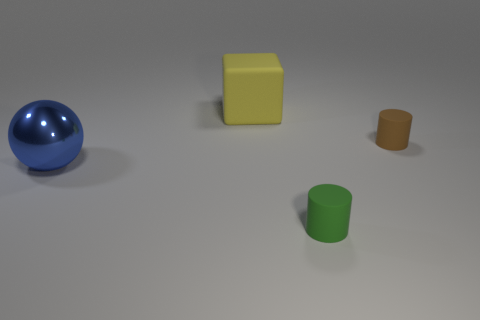Is there anything else that is made of the same material as the big blue thing?
Offer a terse response. No. There is a thing that is to the left of the cube; what size is it?
Make the answer very short. Large. What is the color of the thing that is in front of the big yellow matte object and behind the big metal object?
Ensure brevity in your answer.  Brown. Does the cylinder that is in front of the tiny brown object have the same material as the large yellow block?
Provide a succinct answer. Yes. There is a sphere; does it have the same color as the cylinder behind the tiny green rubber object?
Ensure brevity in your answer.  No. There is a large yellow cube; are there any large yellow rubber blocks behind it?
Keep it short and to the point. No. There is a thing that is on the left side of the large matte thing; is its size the same as the rubber thing in front of the large blue metallic ball?
Offer a very short reply. No. Is there a gray shiny cylinder that has the same size as the green matte cylinder?
Keep it short and to the point. No. There is a small object in front of the blue thing; does it have the same shape as the blue shiny thing?
Your response must be concise. No. There is a small cylinder behind the large blue object; what material is it?
Your response must be concise. Rubber. 